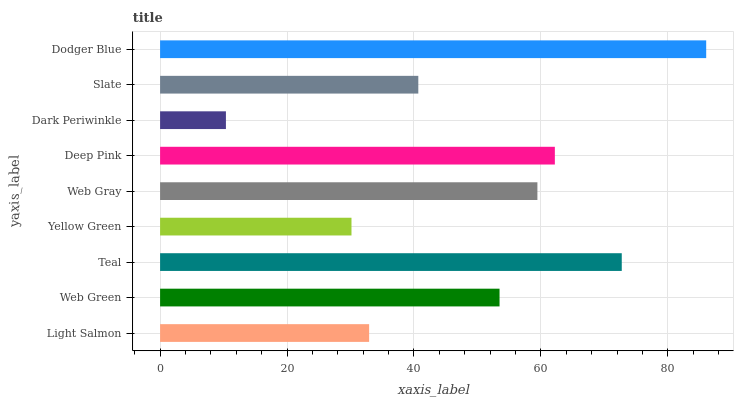Is Dark Periwinkle the minimum?
Answer yes or no. Yes. Is Dodger Blue the maximum?
Answer yes or no. Yes. Is Web Green the minimum?
Answer yes or no. No. Is Web Green the maximum?
Answer yes or no. No. Is Web Green greater than Light Salmon?
Answer yes or no. Yes. Is Light Salmon less than Web Green?
Answer yes or no. Yes. Is Light Salmon greater than Web Green?
Answer yes or no. No. Is Web Green less than Light Salmon?
Answer yes or no. No. Is Web Green the high median?
Answer yes or no. Yes. Is Web Green the low median?
Answer yes or no. Yes. Is Yellow Green the high median?
Answer yes or no. No. Is Light Salmon the low median?
Answer yes or no. No. 